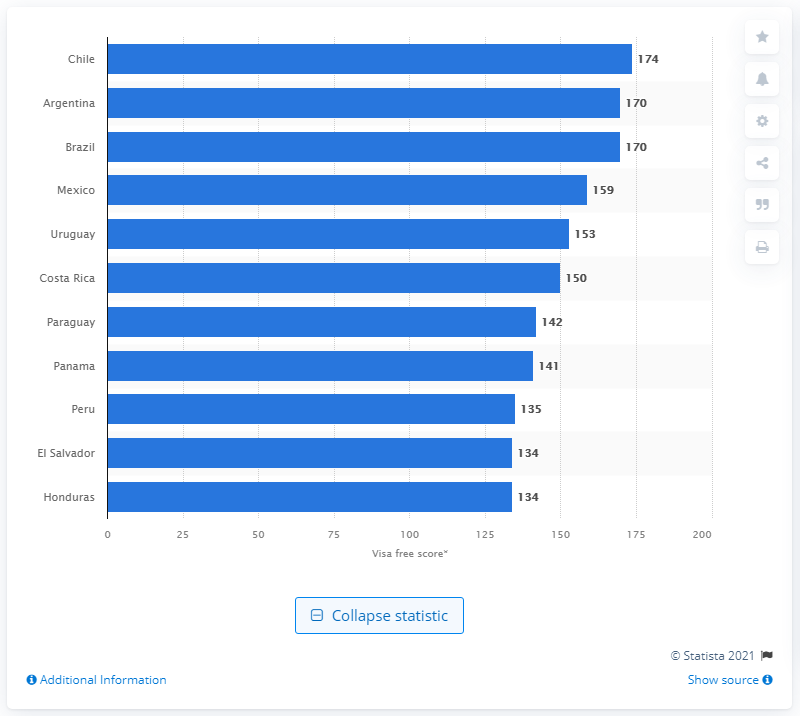Identify some key points in this picture. Chile's visa-free score was 174. Argentina and Brazil both received a visa-free score of 170. 